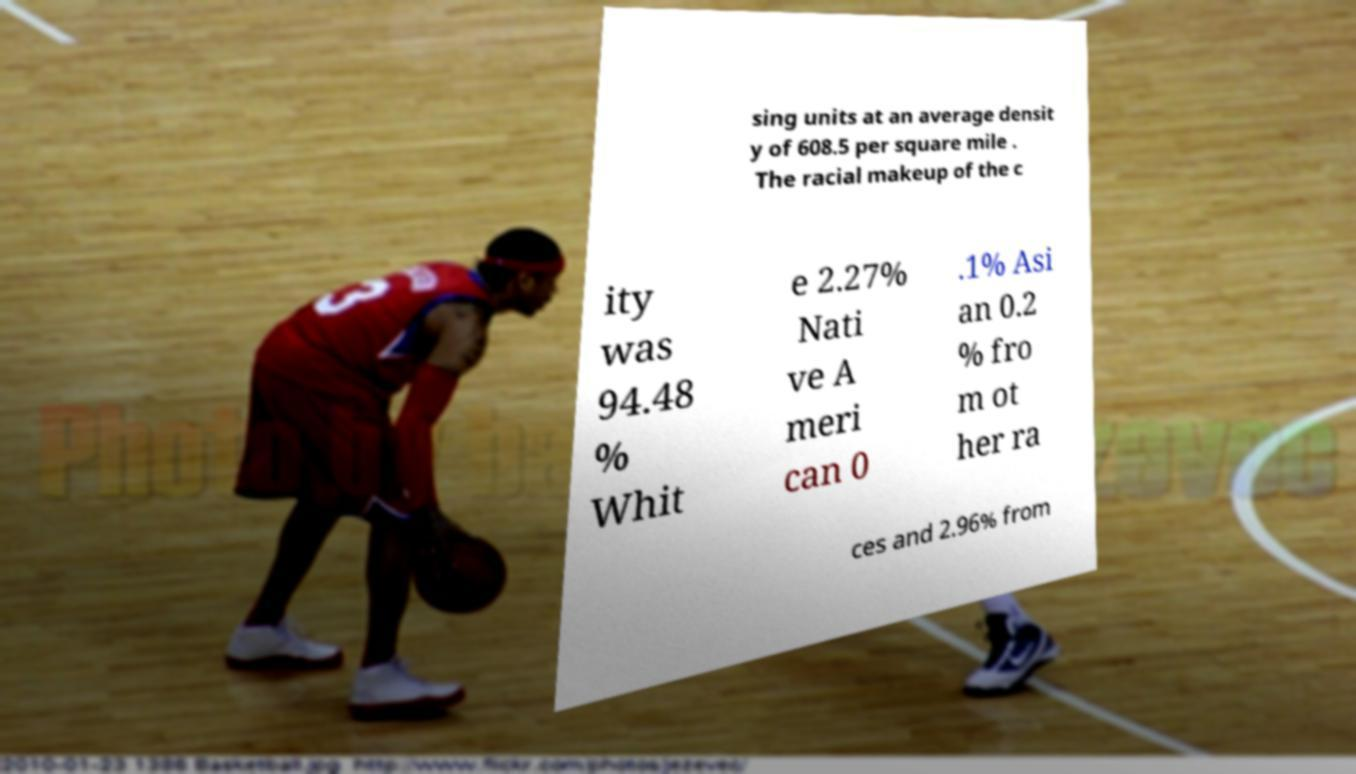Can you accurately transcribe the text from the provided image for me? sing units at an average densit y of 608.5 per square mile . The racial makeup of the c ity was 94.48 % Whit e 2.27% Nati ve A meri can 0 .1% Asi an 0.2 % fro m ot her ra ces and 2.96% from 